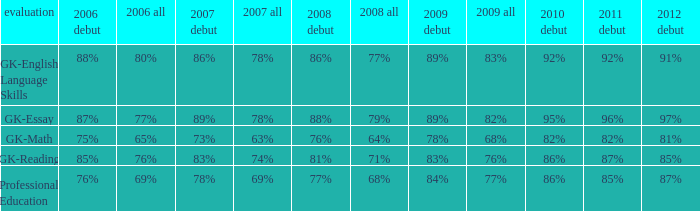What is the fraction for all in 2008 when all in 2007 was 69%? 68%. 